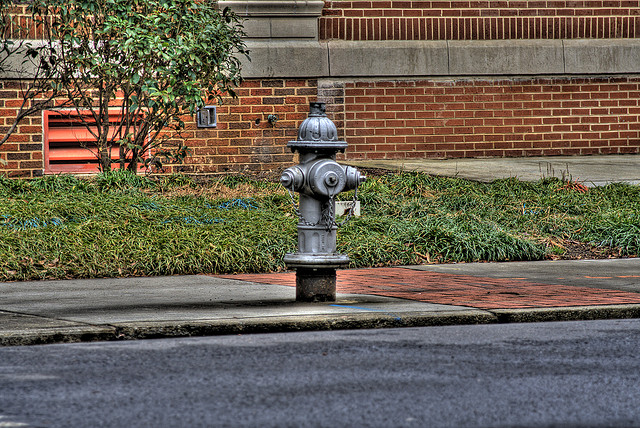<image>What dog is the hydrant depicting? The hydrant is not depicting a specific breed of dog. It can be 'german shepherd', 'bulldog', 'lab'. What dog is the hydrant depicting? The image does not depict any specific dog. 